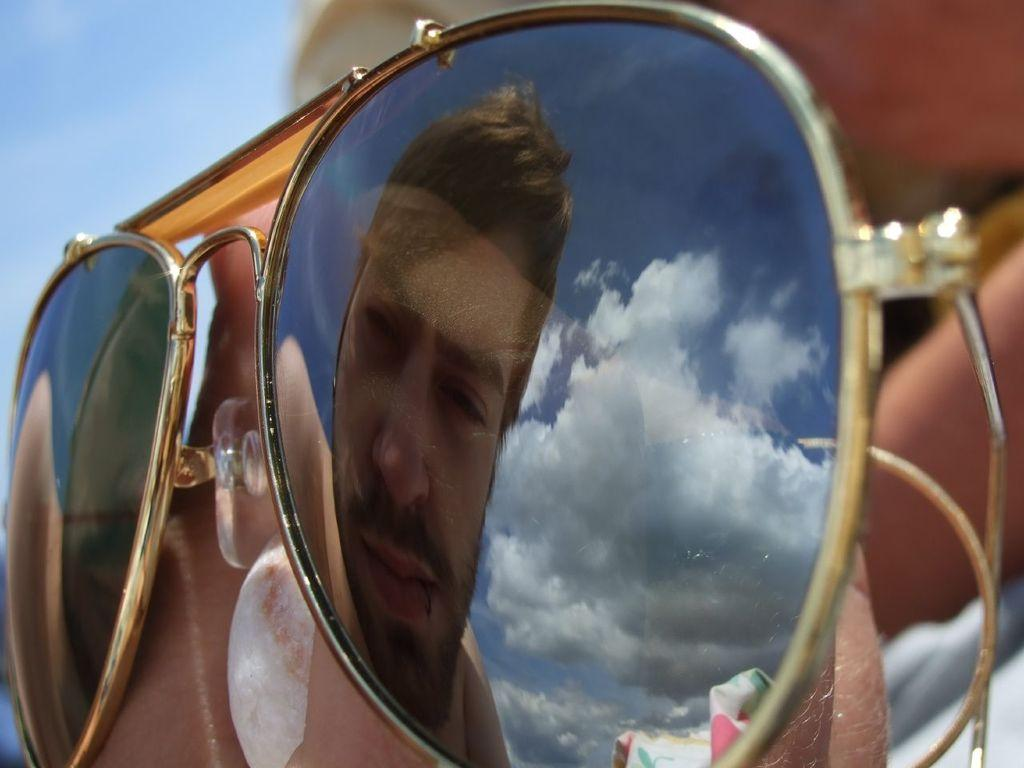What is the main subject in the foreground of the image? There is a person in the foreground of the image. What is the person wearing in the image? The person is wearing goggles. What can be seen in the reflection of the goggles? The goggles reflect another person. What is visible at the top of the image? The sky is visible at the top of the image. How many oranges are hanging from the faucet in the image? There is no faucet or oranges present in the image. What is the person's tendency to interact with others in the image? The image does not provide information about the person's tendency to interact with others. 